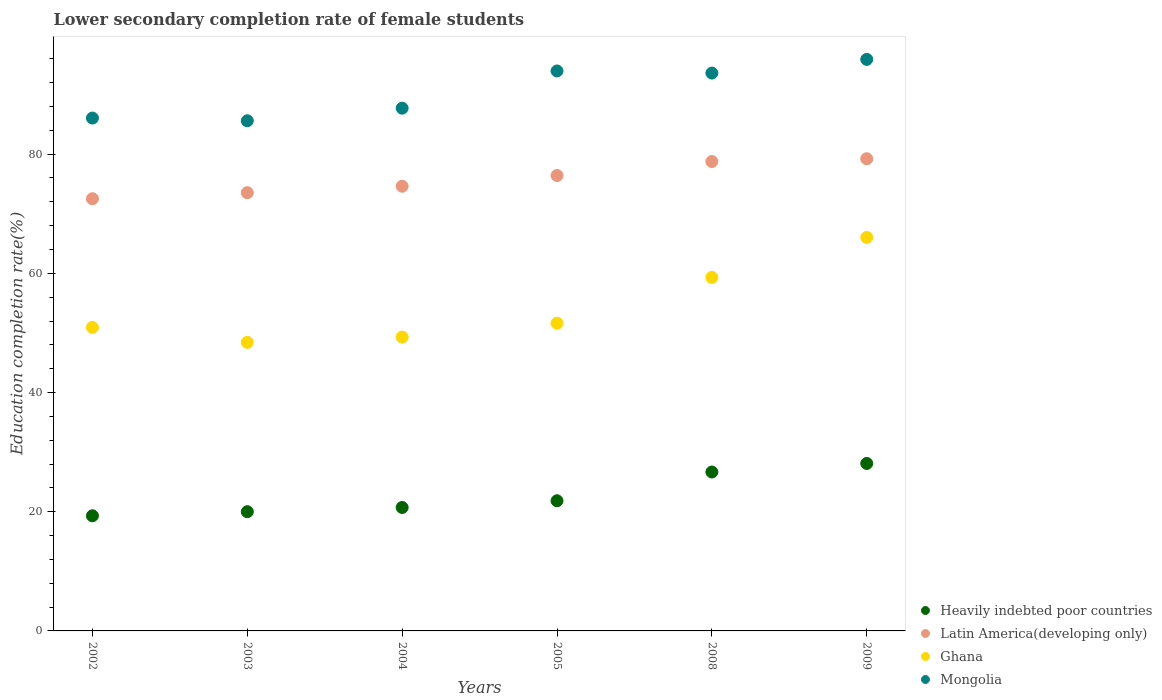Is the number of dotlines equal to the number of legend labels?
Your answer should be very brief. Yes. What is the lower secondary completion rate of female students in Ghana in 2004?
Make the answer very short. 49.3. Across all years, what is the maximum lower secondary completion rate of female students in Heavily indebted poor countries?
Provide a short and direct response. 28.1. Across all years, what is the minimum lower secondary completion rate of female students in Heavily indebted poor countries?
Provide a short and direct response. 19.32. In which year was the lower secondary completion rate of female students in Heavily indebted poor countries minimum?
Give a very brief answer. 2002. What is the total lower secondary completion rate of female students in Heavily indebted poor countries in the graph?
Your answer should be very brief. 136.63. What is the difference between the lower secondary completion rate of female students in Latin America(developing only) in 2005 and that in 2008?
Make the answer very short. -2.35. What is the difference between the lower secondary completion rate of female students in Heavily indebted poor countries in 2002 and the lower secondary completion rate of female students in Ghana in 2009?
Keep it short and to the point. -46.71. What is the average lower secondary completion rate of female students in Mongolia per year?
Your answer should be compact. 90.47. In the year 2009, what is the difference between the lower secondary completion rate of female students in Heavily indebted poor countries and lower secondary completion rate of female students in Latin America(developing only)?
Give a very brief answer. -51.13. In how many years, is the lower secondary completion rate of female students in Latin America(developing only) greater than 68 %?
Provide a succinct answer. 6. What is the ratio of the lower secondary completion rate of female students in Heavily indebted poor countries in 2002 to that in 2004?
Your answer should be compact. 0.93. Is the lower secondary completion rate of female students in Mongolia in 2004 less than that in 2009?
Give a very brief answer. Yes. What is the difference between the highest and the second highest lower secondary completion rate of female students in Mongolia?
Make the answer very short. 1.94. What is the difference between the highest and the lowest lower secondary completion rate of female students in Ghana?
Give a very brief answer. 17.62. Is it the case that in every year, the sum of the lower secondary completion rate of female students in Ghana and lower secondary completion rate of female students in Mongolia  is greater than the sum of lower secondary completion rate of female students in Latin America(developing only) and lower secondary completion rate of female students in Heavily indebted poor countries?
Ensure brevity in your answer.  No. What is the difference between two consecutive major ticks on the Y-axis?
Your response must be concise. 20. Does the graph contain grids?
Ensure brevity in your answer.  No. Where does the legend appear in the graph?
Ensure brevity in your answer.  Bottom right. How are the legend labels stacked?
Give a very brief answer. Vertical. What is the title of the graph?
Provide a short and direct response. Lower secondary completion rate of female students. Does "Guinea" appear as one of the legend labels in the graph?
Offer a very short reply. No. What is the label or title of the Y-axis?
Keep it short and to the point. Education completion rate(%). What is the Education completion rate(%) in Heavily indebted poor countries in 2002?
Your answer should be compact. 19.32. What is the Education completion rate(%) in Latin America(developing only) in 2002?
Offer a terse response. 72.52. What is the Education completion rate(%) of Ghana in 2002?
Provide a succinct answer. 50.93. What is the Education completion rate(%) of Mongolia in 2002?
Make the answer very short. 86.06. What is the Education completion rate(%) of Heavily indebted poor countries in 2003?
Provide a succinct answer. 20. What is the Education completion rate(%) of Latin America(developing only) in 2003?
Keep it short and to the point. 73.53. What is the Education completion rate(%) of Ghana in 2003?
Your answer should be very brief. 48.41. What is the Education completion rate(%) of Mongolia in 2003?
Provide a short and direct response. 85.6. What is the Education completion rate(%) in Heavily indebted poor countries in 2004?
Provide a short and direct response. 20.71. What is the Education completion rate(%) of Latin America(developing only) in 2004?
Provide a succinct answer. 74.61. What is the Education completion rate(%) of Ghana in 2004?
Offer a very short reply. 49.3. What is the Education completion rate(%) of Mongolia in 2004?
Ensure brevity in your answer.  87.71. What is the Education completion rate(%) in Heavily indebted poor countries in 2005?
Offer a terse response. 21.84. What is the Education completion rate(%) in Latin America(developing only) in 2005?
Offer a terse response. 76.41. What is the Education completion rate(%) in Ghana in 2005?
Keep it short and to the point. 51.63. What is the Education completion rate(%) of Mongolia in 2005?
Your answer should be compact. 93.96. What is the Education completion rate(%) in Heavily indebted poor countries in 2008?
Keep it short and to the point. 26.66. What is the Education completion rate(%) in Latin America(developing only) in 2008?
Provide a succinct answer. 78.76. What is the Education completion rate(%) in Ghana in 2008?
Make the answer very short. 59.32. What is the Education completion rate(%) in Mongolia in 2008?
Your answer should be very brief. 93.6. What is the Education completion rate(%) in Heavily indebted poor countries in 2009?
Offer a very short reply. 28.1. What is the Education completion rate(%) in Latin America(developing only) in 2009?
Provide a succinct answer. 79.23. What is the Education completion rate(%) of Ghana in 2009?
Keep it short and to the point. 66.03. What is the Education completion rate(%) in Mongolia in 2009?
Offer a terse response. 95.9. Across all years, what is the maximum Education completion rate(%) of Heavily indebted poor countries?
Provide a short and direct response. 28.1. Across all years, what is the maximum Education completion rate(%) in Latin America(developing only)?
Give a very brief answer. 79.23. Across all years, what is the maximum Education completion rate(%) in Ghana?
Keep it short and to the point. 66.03. Across all years, what is the maximum Education completion rate(%) in Mongolia?
Your answer should be compact. 95.9. Across all years, what is the minimum Education completion rate(%) in Heavily indebted poor countries?
Give a very brief answer. 19.32. Across all years, what is the minimum Education completion rate(%) in Latin America(developing only)?
Offer a very short reply. 72.52. Across all years, what is the minimum Education completion rate(%) in Ghana?
Give a very brief answer. 48.41. Across all years, what is the minimum Education completion rate(%) in Mongolia?
Keep it short and to the point. 85.6. What is the total Education completion rate(%) in Heavily indebted poor countries in the graph?
Provide a succinct answer. 136.63. What is the total Education completion rate(%) in Latin America(developing only) in the graph?
Your response must be concise. 455.06. What is the total Education completion rate(%) in Ghana in the graph?
Ensure brevity in your answer.  325.62. What is the total Education completion rate(%) of Mongolia in the graph?
Provide a short and direct response. 542.82. What is the difference between the Education completion rate(%) in Heavily indebted poor countries in 2002 and that in 2003?
Your answer should be compact. -0.69. What is the difference between the Education completion rate(%) in Latin America(developing only) in 2002 and that in 2003?
Offer a terse response. -1.01. What is the difference between the Education completion rate(%) in Ghana in 2002 and that in 2003?
Offer a terse response. 2.51. What is the difference between the Education completion rate(%) of Mongolia in 2002 and that in 2003?
Provide a short and direct response. 0.46. What is the difference between the Education completion rate(%) in Heavily indebted poor countries in 2002 and that in 2004?
Give a very brief answer. -1.4. What is the difference between the Education completion rate(%) in Latin America(developing only) in 2002 and that in 2004?
Your response must be concise. -2.1. What is the difference between the Education completion rate(%) of Ghana in 2002 and that in 2004?
Give a very brief answer. 1.63. What is the difference between the Education completion rate(%) of Mongolia in 2002 and that in 2004?
Offer a very short reply. -1.66. What is the difference between the Education completion rate(%) of Heavily indebted poor countries in 2002 and that in 2005?
Provide a short and direct response. -2.52. What is the difference between the Education completion rate(%) of Latin America(developing only) in 2002 and that in 2005?
Provide a short and direct response. -3.9. What is the difference between the Education completion rate(%) in Ghana in 2002 and that in 2005?
Ensure brevity in your answer.  -0.7. What is the difference between the Education completion rate(%) in Mongolia in 2002 and that in 2005?
Your response must be concise. -7.9. What is the difference between the Education completion rate(%) of Heavily indebted poor countries in 2002 and that in 2008?
Your response must be concise. -7.34. What is the difference between the Education completion rate(%) of Latin America(developing only) in 2002 and that in 2008?
Your response must be concise. -6.24. What is the difference between the Education completion rate(%) of Ghana in 2002 and that in 2008?
Make the answer very short. -8.39. What is the difference between the Education completion rate(%) of Mongolia in 2002 and that in 2008?
Give a very brief answer. -7.55. What is the difference between the Education completion rate(%) of Heavily indebted poor countries in 2002 and that in 2009?
Your answer should be very brief. -8.78. What is the difference between the Education completion rate(%) in Latin America(developing only) in 2002 and that in 2009?
Keep it short and to the point. -6.71. What is the difference between the Education completion rate(%) in Ghana in 2002 and that in 2009?
Offer a terse response. -15.1. What is the difference between the Education completion rate(%) in Mongolia in 2002 and that in 2009?
Your response must be concise. -9.84. What is the difference between the Education completion rate(%) of Heavily indebted poor countries in 2003 and that in 2004?
Provide a succinct answer. -0.71. What is the difference between the Education completion rate(%) of Latin America(developing only) in 2003 and that in 2004?
Provide a succinct answer. -1.09. What is the difference between the Education completion rate(%) of Ghana in 2003 and that in 2004?
Your answer should be very brief. -0.89. What is the difference between the Education completion rate(%) of Mongolia in 2003 and that in 2004?
Your answer should be very brief. -2.11. What is the difference between the Education completion rate(%) in Heavily indebted poor countries in 2003 and that in 2005?
Keep it short and to the point. -1.83. What is the difference between the Education completion rate(%) of Latin America(developing only) in 2003 and that in 2005?
Give a very brief answer. -2.88. What is the difference between the Education completion rate(%) in Ghana in 2003 and that in 2005?
Your answer should be compact. -3.21. What is the difference between the Education completion rate(%) in Mongolia in 2003 and that in 2005?
Your answer should be compact. -8.36. What is the difference between the Education completion rate(%) in Heavily indebted poor countries in 2003 and that in 2008?
Keep it short and to the point. -6.66. What is the difference between the Education completion rate(%) of Latin America(developing only) in 2003 and that in 2008?
Your answer should be compact. -5.23. What is the difference between the Education completion rate(%) of Ghana in 2003 and that in 2008?
Offer a very short reply. -10.9. What is the difference between the Education completion rate(%) in Mongolia in 2003 and that in 2008?
Your response must be concise. -8. What is the difference between the Education completion rate(%) in Heavily indebted poor countries in 2003 and that in 2009?
Provide a short and direct response. -8.09. What is the difference between the Education completion rate(%) of Latin America(developing only) in 2003 and that in 2009?
Your answer should be compact. -5.7. What is the difference between the Education completion rate(%) in Ghana in 2003 and that in 2009?
Offer a terse response. -17.62. What is the difference between the Education completion rate(%) of Mongolia in 2003 and that in 2009?
Keep it short and to the point. -10.3. What is the difference between the Education completion rate(%) in Heavily indebted poor countries in 2004 and that in 2005?
Make the answer very short. -1.12. What is the difference between the Education completion rate(%) in Latin America(developing only) in 2004 and that in 2005?
Make the answer very short. -1.8. What is the difference between the Education completion rate(%) in Ghana in 2004 and that in 2005?
Provide a succinct answer. -2.33. What is the difference between the Education completion rate(%) in Mongolia in 2004 and that in 2005?
Provide a succinct answer. -6.24. What is the difference between the Education completion rate(%) of Heavily indebted poor countries in 2004 and that in 2008?
Provide a short and direct response. -5.95. What is the difference between the Education completion rate(%) in Latin America(developing only) in 2004 and that in 2008?
Provide a succinct answer. -4.14. What is the difference between the Education completion rate(%) in Ghana in 2004 and that in 2008?
Provide a short and direct response. -10.02. What is the difference between the Education completion rate(%) in Mongolia in 2004 and that in 2008?
Provide a short and direct response. -5.89. What is the difference between the Education completion rate(%) in Heavily indebted poor countries in 2004 and that in 2009?
Your answer should be compact. -7.38. What is the difference between the Education completion rate(%) in Latin America(developing only) in 2004 and that in 2009?
Your answer should be very brief. -4.62. What is the difference between the Education completion rate(%) of Ghana in 2004 and that in 2009?
Provide a short and direct response. -16.73. What is the difference between the Education completion rate(%) in Mongolia in 2004 and that in 2009?
Provide a short and direct response. -8.19. What is the difference between the Education completion rate(%) in Heavily indebted poor countries in 2005 and that in 2008?
Ensure brevity in your answer.  -4.83. What is the difference between the Education completion rate(%) in Latin America(developing only) in 2005 and that in 2008?
Provide a succinct answer. -2.35. What is the difference between the Education completion rate(%) of Ghana in 2005 and that in 2008?
Your answer should be very brief. -7.69. What is the difference between the Education completion rate(%) in Mongolia in 2005 and that in 2008?
Provide a succinct answer. 0.36. What is the difference between the Education completion rate(%) in Heavily indebted poor countries in 2005 and that in 2009?
Give a very brief answer. -6.26. What is the difference between the Education completion rate(%) in Latin America(developing only) in 2005 and that in 2009?
Provide a short and direct response. -2.82. What is the difference between the Education completion rate(%) of Ghana in 2005 and that in 2009?
Ensure brevity in your answer.  -14.41. What is the difference between the Education completion rate(%) of Mongolia in 2005 and that in 2009?
Give a very brief answer. -1.94. What is the difference between the Education completion rate(%) in Heavily indebted poor countries in 2008 and that in 2009?
Ensure brevity in your answer.  -1.44. What is the difference between the Education completion rate(%) of Latin America(developing only) in 2008 and that in 2009?
Offer a terse response. -0.47. What is the difference between the Education completion rate(%) of Ghana in 2008 and that in 2009?
Your answer should be compact. -6.71. What is the difference between the Education completion rate(%) of Mongolia in 2008 and that in 2009?
Your answer should be very brief. -2.3. What is the difference between the Education completion rate(%) of Heavily indebted poor countries in 2002 and the Education completion rate(%) of Latin America(developing only) in 2003?
Make the answer very short. -54.21. What is the difference between the Education completion rate(%) in Heavily indebted poor countries in 2002 and the Education completion rate(%) in Ghana in 2003?
Ensure brevity in your answer.  -29.1. What is the difference between the Education completion rate(%) in Heavily indebted poor countries in 2002 and the Education completion rate(%) in Mongolia in 2003?
Provide a short and direct response. -66.28. What is the difference between the Education completion rate(%) of Latin America(developing only) in 2002 and the Education completion rate(%) of Ghana in 2003?
Give a very brief answer. 24.1. What is the difference between the Education completion rate(%) in Latin America(developing only) in 2002 and the Education completion rate(%) in Mongolia in 2003?
Your answer should be very brief. -13.08. What is the difference between the Education completion rate(%) of Ghana in 2002 and the Education completion rate(%) of Mongolia in 2003?
Offer a very short reply. -34.67. What is the difference between the Education completion rate(%) of Heavily indebted poor countries in 2002 and the Education completion rate(%) of Latin America(developing only) in 2004?
Provide a succinct answer. -55.3. What is the difference between the Education completion rate(%) of Heavily indebted poor countries in 2002 and the Education completion rate(%) of Ghana in 2004?
Offer a terse response. -29.98. What is the difference between the Education completion rate(%) of Heavily indebted poor countries in 2002 and the Education completion rate(%) of Mongolia in 2004?
Provide a succinct answer. -68.39. What is the difference between the Education completion rate(%) in Latin America(developing only) in 2002 and the Education completion rate(%) in Ghana in 2004?
Offer a very short reply. 23.22. What is the difference between the Education completion rate(%) in Latin America(developing only) in 2002 and the Education completion rate(%) in Mongolia in 2004?
Make the answer very short. -15.19. What is the difference between the Education completion rate(%) in Ghana in 2002 and the Education completion rate(%) in Mongolia in 2004?
Your answer should be compact. -36.78. What is the difference between the Education completion rate(%) in Heavily indebted poor countries in 2002 and the Education completion rate(%) in Latin America(developing only) in 2005?
Provide a succinct answer. -57.1. What is the difference between the Education completion rate(%) in Heavily indebted poor countries in 2002 and the Education completion rate(%) in Ghana in 2005?
Provide a succinct answer. -32.31. What is the difference between the Education completion rate(%) of Heavily indebted poor countries in 2002 and the Education completion rate(%) of Mongolia in 2005?
Ensure brevity in your answer.  -74.64. What is the difference between the Education completion rate(%) of Latin America(developing only) in 2002 and the Education completion rate(%) of Ghana in 2005?
Give a very brief answer. 20.89. What is the difference between the Education completion rate(%) in Latin America(developing only) in 2002 and the Education completion rate(%) in Mongolia in 2005?
Your answer should be compact. -21.44. What is the difference between the Education completion rate(%) in Ghana in 2002 and the Education completion rate(%) in Mongolia in 2005?
Provide a succinct answer. -43.03. What is the difference between the Education completion rate(%) in Heavily indebted poor countries in 2002 and the Education completion rate(%) in Latin America(developing only) in 2008?
Give a very brief answer. -59.44. What is the difference between the Education completion rate(%) of Heavily indebted poor countries in 2002 and the Education completion rate(%) of Ghana in 2008?
Make the answer very short. -40. What is the difference between the Education completion rate(%) of Heavily indebted poor countries in 2002 and the Education completion rate(%) of Mongolia in 2008?
Ensure brevity in your answer.  -74.28. What is the difference between the Education completion rate(%) in Latin America(developing only) in 2002 and the Education completion rate(%) in Ghana in 2008?
Your response must be concise. 13.2. What is the difference between the Education completion rate(%) of Latin America(developing only) in 2002 and the Education completion rate(%) of Mongolia in 2008?
Give a very brief answer. -21.08. What is the difference between the Education completion rate(%) in Ghana in 2002 and the Education completion rate(%) in Mongolia in 2008?
Keep it short and to the point. -42.67. What is the difference between the Education completion rate(%) in Heavily indebted poor countries in 2002 and the Education completion rate(%) in Latin America(developing only) in 2009?
Offer a terse response. -59.91. What is the difference between the Education completion rate(%) of Heavily indebted poor countries in 2002 and the Education completion rate(%) of Ghana in 2009?
Offer a very short reply. -46.71. What is the difference between the Education completion rate(%) of Heavily indebted poor countries in 2002 and the Education completion rate(%) of Mongolia in 2009?
Provide a short and direct response. -76.58. What is the difference between the Education completion rate(%) of Latin America(developing only) in 2002 and the Education completion rate(%) of Ghana in 2009?
Offer a terse response. 6.48. What is the difference between the Education completion rate(%) in Latin America(developing only) in 2002 and the Education completion rate(%) in Mongolia in 2009?
Keep it short and to the point. -23.38. What is the difference between the Education completion rate(%) of Ghana in 2002 and the Education completion rate(%) of Mongolia in 2009?
Make the answer very short. -44.97. What is the difference between the Education completion rate(%) in Heavily indebted poor countries in 2003 and the Education completion rate(%) in Latin America(developing only) in 2004?
Offer a terse response. -54.61. What is the difference between the Education completion rate(%) of Heavily indebted poor countries in 2003 and the Education completion rate(%) of Ghana in 2004?
Your answer should be compact. -29.3. What is the difference between the Education completion rate(%) of Heavily indebted poor countries in 2003 and the Education completion rate(%) of Mongolia in 2004?
Ensure brevity in your answer.  -67.71. What is the difference between the Education completion rate(%) of Latin America(developing only) in 2003 and the Education completion rate(%) of Ghana in 2004?
Make the answer very short. 24.23. What is the difference between the Education completion rate(%) in Latin America(developing only) in 2003 and the Education completion rate(%) in Mongolia in 2004?
Make the answer very short. -14.18. What is the difference between the Education completion rate(%) of Ghana in 2003 and the Education completion rate(%) of Mongolia in 2004?
Keep it short and to the point. -39.3. What is the difference between the Education completion rate(%) in Heavily indebted poor countries in 2003 and the Education completion rate(%) in Latin America(developing only) in 2005?
Offer a terse response. -56.41. What is the difference between the Education completion rate(%) of Heavily indebted poor countries in 2003 and the Education completion rate(%) of Ghana in 2005?
Provide a short and direct response. -31.62. What is the difference between the Education completion rate(%) of Heavily indebted poor countries in 2003 and the Education completion rate(%) of Mongolia in 2005?
Ensure brevity in your answer.  -73.95. What is the difference between the Education completion rate(%) of Latin America(developing only) in 2003 and the Education completion rate(%) of Ghana in 2005?
Provide a short and direct response. 21.9. What is the difference between the Education completion rate(%) in Latin America(developing only) in 2003 and the Education completion rate(%) in Mongolia in 2005?
Make the answer very short. -20.43. What is the difference between the Education completion rate(%) in Ghana in 2003 and the Education completion rate(%) in Mongolia in 2005?
Your answer should be very brief. -45.54. What is the difference between the Education completion rate(%) in Heavily indebted poor countries in 2003 and the Education completion rate(%) in Latin America(developing only) in 2008?
Your response must be concise. -58.75. What is the difference between the Education completion rate(%) of Heavily indebted poor countries in 2003 and the Education completion rate(%) of Ghana in 2008?
Ensure brevity in your answer.  -39.31. What is the difference between the Education completion rate(%) in Heavily indebted poor countries in 2003 and the Education completion rate(%) in Mongolia in 2008?
Your response must be concise. -73.6. What is the difference between the Education completion rate(%) in Latin America(developing only) in 2003 and the Education completion rate(%) in Ghana in 2008?
Your response must be concise. 14.21. What is the difference between the Education completion rate(%) of Latin America(developing only) in 2003 and the Education completion rate(%) of Mongolia in 2008?
Keep it short and to the point. -20.07. What is the difference between the Education completion rate(%) in Ghana in 2003 and the Education completion rate(%) in Mongolia in 2008?
Offer a very short reply. -45.19. What is the difference between the Education completion rate(%) in Heavily indebted poor countries in 2003 and the Education completion rate(%) in Latin America(developing only) in 2009?
Make the answer very short. -59.22. What is the difference between the Education completion rate(%) of Heavily indebted poor countries in 2003 and the Education completion rate(%) of Ghana in 2009?
Make the answer very short. -46.03. What is the difference between the Education completion rate(%) in Heavily indebted poor countries in 2003 and the Education completion rate(%) in Mongolia in 2009?
Provide a short and direct response. -75.89. What is the difference between the Education completion rate(%) of Latin America(developing only) in 2003 and the Education completion rate(%) of Ghana in 2009?
Provide a succinct answer. 7.5. What is the difference between the Education completion rate(%) in Latin America(developing only) in 2003 and the Education completion rate(%) in Mongolia in 2009?
Ensure brevity in your answer.  -22.37. What is the difference between the Education completion rate(%) in Ghana in 2003 and the Education completion rate(%) in Mongolia in 2009?
Provide a short and direct response. -47.48. What is the difference between the Education completion rate(%) of Heavily indebted poor countries in 2004 and the Education completion rate(%) of Latin America(developing only) in 2005?
Your answer should be compact. -55.7. What is the difference between the Education completion rate(%) of Heavily indebted poor countries in 2004 and the Education completion rate(%) of Ghana in 2005?
Provide a succinct answer. -30.91. What is the difference between the Education completion rate(%) in Heavily indebted poor countries in 2004 and the Education completion rate(%) in Mongolia in 2005?
Offer a terse response. -73.24. What is the difference between the Education completion rate(%) in Latin America(developing only) in 2004 and the Education completion rate(%) in Ghana in 2005?
Keep it short and to the point. 22.99. What is the difference between the Education completion rate(%) in Latin America(developing only) in 2004 and the Education completion rate(%) in Mongolia in 2005?
Provide a succinct answer. -19.34. What is the difference between the Education completion rate(%) in Ghana in 2004 and the Education completion rate(%) in Mongolia in 2005?
Offer a very short reply. -44.66. What is the difference between the Education completion rate(%) in Heavily indebted poor countries in 2004 and the Education completion rate(%) in Latin America(developing only) in 2008?
Ensure brevity in your answer.  -58.05. What is the difference between the Education completion rate(%) of Heavily indebted poor countries in 2004 and the Education completion rate(%) of Ghana in 2008?
Your response must be concise. -38.6. What is the difference between the Education completion rate(%) of Heavily indebted poor countries in 2004 and the Education completion rate(%) of Mongolia in 2008?
Make the answer very short. -72.89. What is the difference between the Education completion rate(%) of Latin America(developing only) in 2004 and the Education completion rate(%) of Ghana in 2008?
Offer a very short reply. 15.3. What is the difference between the Education completion rate(%) of Latin America(developing only) in 2004 and the Education completion rate(%) of Mongolia in 2008?
Offer a very short reply. -18.99. What is the difference between the Education completion rate(%) in Ghana in 2004 and the Education completion rate(%) in Mongolia in 2008?
Offer a terse response. -44.3. What is the difference between the Education completion rate(%) of Heavily indebted poor countries in 2004 and the Education completion rate(%) of Latin America(developing only) in 2009?
Ensure brevity in your answer.  -58.52. What is the difference between the Education completion rate(%) in Heavily indebted poor countries in 2004 and the Education completion rate(%) in Ghana in 2009?
Make the answer very short. -45.32. What is the difference between the Education completion rate(%) of Heavily indebted poor countries in 2004 and the Education completion rate(%) of Mongolia in 2009?
Provide a short and direct response. -75.18. What is the difference between the Education completion rate(%) of Latin America(developing only) in 2004 and the Education completion rate(%) of Ghana in 2009?
Keep it short and to the point. 8.58. What is the difference between the Education completion rate(%) of Latin America(developing only) in 2004 and the Education completion rate(%) of Mongolia in 2009?
Offer a terse response. -21.28. What is the difference between the Education completion rate(%) in Ghana in 2004 and the Education completion rate(%) in Mongolia in 2009?
Your response must be concise. -46.6. What is the difference between the Education completion rate(%) of Heavily indebted poor countries in 2005 and the Education completion rate(%) of Latin America(developing only) in 2008?
Give a very brief answer. -56.92. What is the difference between the Education completion rate(%) in Heavily indebted poor countries in 2005 and the Education completion rate(%) in Ghana in 2008?
Provide a succinct answer. -37.48. What is the difference between the Education completion rate(%) in Heavily indebted poor countries in 2005 and the Education completion rate(%) in Mongolia in 2008?
Make the answer very short. -71.76. What is the difference between the Education completion rate(%) in Latin America(developing only) in 2005 and the Education completion rate(%) in Ghana in 2008?
Provide a short and direct response. 17.1. What is the difference between the Education completion rate(%) in Latin America(developing only) in 2005 and the Education completion rate(%) in Mongolia in 2008?
Make the answer very short. -17.19. What is the difference between the Education completion rate(%) in Ghana in 2005 and the Education completion rate(%) in Mongolia in 2008?
Your answer should be compact. -41.97. What is the difference between the Education completion rate(%) in Heavily indebted poor countries in 2005 and the Education completion rate(%) in Latin America(developing only) in 2009?
Your response must be concise. -57.39. What is the difference between the Education completion rate(%) in Heavily indebted poor countries in 2005 and the Education completion rate(%) in Ghana in 2009?
Offer a terse response. -44.2. What is the difference between the Education completion rate(%) in Heavily indebted poor countries in 2005 and the Education completion rate(%) in Mongolia in 2009?
Provide a succinct answer. -74.06. What is the difference between the Education completion rate(%) of Latin America(developing only) in 2005 and the Education completion rate(%) of Ghana in 2009?
Ensure brevity in your answer.  10.38. What is the difference between the Education completion rate(%) of Latin America(developing only) in 2005 and the Education completion rate(%) of Mongolia in 2009?
Provide a succinct answer. -19.48. What is the difference between the Education completion rate(%) of Ghana in 2005 and the Education completion rate(%) of Mongolia in 2009?
Provide a short and direct response. -44.27. What is the difference between the Education completion rate(%) in Heavily indebted poor countries in 2008 and the Education completion rate(%) in Latin America(developing only) in 2009?
Keep it short and to the point. -52.57. What is the difference between the Education completion rate(%) in Heavily indebted poor countries in 2008 and the Education completion rate(%) in Ghana in 2009?
Your response must be concise. -39.37. What is the difference between the Education completion rate(%) of Heavily indebted poor countries in 2008 and the Education completion rate(%) of Mongolia in 2009?
Your answer should be very brief. -69.23. What is the difference between the Education completion rate(%) of Latin America(developing only) in 2008 and the Education completion rate(%) of Ghana in 2009?
Your response must be concise. 12.73. What is the difference between the Education completion rate(%) in Latin America(developing only) in 2008 and the Education completion rate(%) in Mongolia in 2009?
Your answer should be compact. -17.14. What is the difference between the Education completion rate(%) in Ghana in 2008 and the Education completion rate(%) in Mongolia in 2009?
Provide a short and direct response. -36.58. What is the average Education completion rate(%) of Heavily indebted poor countries per year?
Your answer should be very brief. 22.77. What is the average Education completion rate(%) in Latin America(developing only) per year?
Give a very brief answer. 75.84. What is the average Education completion rate(%) of Ghana per year?
Give a very brief answer. 54.27. What is the average Education completion rate(%) in Mongolia per year?
Make the answer very short. 90.47. In the year 2002, what is the difference between the Education completion rate(%) in Heavily indebted poor countries and Education completion rate(%) in Latin America(developing only)?
Provide a succinct answer. -53.2. In the year 2002, what is the difference between the Education completion rate(%) in Heavily indebted poor countries and Education completion rate(%) in Ghana?
Your response must be concise. -31.61. In the year 2002, what is the difference between the Education completion rate(%) of Heavily indebted poor countries and Education completion rate(%) of Mongolia?
Provide a short and direct response. -66.74. In the year 2002, what is the difference between the Education completion rate(%) of Latin America(developing only) and Education completion rate(%) of Ghana?
Offer a very short reply. 21.59. In the year 2002, what is the difference between the Education completion rate(%) in Latin America(developing only) and Education completion rate(%) in Mongolia?
Offer a terse response. -13.54. In the year 2002, what is the difference between the Education completion rate(%) of Ghana and Education completion rate(%) of Mongolia?
Ensure brevity in your answer.  -35.13. In the year 2003, what is the difference between the Education completion rate(%) in Heavily indebted poor countries and Education completion rate(%) in Latin America(developing only)?
Offer a very short reply. -53.52. In the year 2003, what is the difference between the Education completion rate(%) in Heavily indebted poor countries and Education completion rate(%) in Ghana?
Provide a short and direct response. -28.41. In the year 2003, what is the difference between the Education completion rate(%) of Heavily indebted poor countries and Education completion rate(%) of Mongolia?
Keep it short and to the point. -65.59. In the year 2003, what is the difference between the Education completion rate(%) in Latin America(developing only) and Education completion rate(%) in Ghana?
Offer a terse response. 25.11. In the year 2003, what is the difference between the Education completion rate(%) in Latin America(developing only) and Education completion rate(%) in Mongolia?
Your answer should be very brief. -12.07. In the year 2003, what is the difference between the Education completion rate(%) in Ghana and Education completion rate(%) in Mongolia?
Provide a succinct answer. -37.18. In the year 2004, what is the difference between the Education completion rate(%) in Heavily indebted poor countries and Education completion rate(%) in Latin America(developing only)?
Offer a very short reply. -53.9. In the year 2004, what is the difference between the Education completion rate(%) in Heavily indebted poor countries and Education completion rate(%) in Ghana?
Your answer should be very brief. -28.59. In the year 2004, what is the difference between the Education completion rate(%) in Heavily indebted poor countries and Education completion rate(%) in Mongolia?
Give a very brief answer. -67. In the year 2004, what is the difference between the Education completion rate(%) of Latin America(developing only) and Education completion rate(%) of Ghana?
Provide a short and direct response. 25.31. In the year 2004, what is the difference between the Education completion rate(%) of Latin America(developing only) and Education completion rate(%) of Mongolia?
Keep it short and to the point. -13.1. In the year 2004, what is the difference between the Education completion rate(%) in Ghana and Education completion rate(%) in Mongolia?
Provide a short and direct response. -38.41. In the year 2005, what is the difference between the Education completion rate(%) of Heavily indebted poor countries and Education completion rate(%) of Latin America(developing only)?
Your response must be concise. -54.58. In the year 2005, what is the difference between the Education completion rate(%) in Heavily indebted poor countries and Education completion rate(%) in Ghana?
Make the answer very short. -29.79. In the year 2005, what is the difference between the Education completion rate(%) in Heavily indebted poor countries and Education completion rate(%) in Mongolia?
Offer a very short reply. -72.12. In the year 2005, what is the difference between the Education completion rate(%) of Latin America(developing only) and Education completion rate(%) of Ghana?
Ensure brevity in your answer.  24.79. In the year 2005, what is the difference between the Education completion rate(%) of Latin America(developing only) and Education completion rate(%) of Mongolia?
Provide a succinct answer. -17.54. In the year 2005, what is the difference between the Education completion rate(%) of Ghana and Education completion rate(%) of Mongolia?
Your response must be concise. -42.33. In the year 2008, what is the difference between the Education completion rate(%) in Heavily indebted poor countries and Education completion rate(%) in Latin America(developing only)?
Make the answer very short. -52.1. In the year 2008, what is the difference between the Education completion rate(%) of Heavily indebted poor countries and Education completion rate(%) of Ghana?
Your response must be concise. -32.66. In the year 2008, what is the difference between the Education completion rate(%) of Heavily indebted poor countries and Education completion rate(%) of Mongolia?
Ensure brevity in your answer.  -66.94. In the year 2008, what is the difference between the Education completion rate(%) in Latin America(developing only) and Education completion rate(%) in Ghana?
Offer a terse response. 19.44. In the year 2008, what is the difference between the Education completion rate(%) of Latin America(developing only) and Education completion rate(%) of Mongolia?
Provide a short and direct response. -14.84. In the year 2008, what is the difference between the Education completion rate(%) in Ghana and Education completion rate(%) in Mongolia?
Ensure brevity in your answer.  -34.28. In the year 2009, what is the difference between the Education completion rate(%) of Heavily indebted poor countries and Education completion rate(%) of Latin America(developing only)?
Offer a very short reply. -51.13. In the year 2009, what is the difference between the Education completion rate(%) in Heavily indebted poor countries and Education completion rate(%) in Ghana?
Your response must be concise. -37.93. In the year 2009, what is the difference between the Education completion rate(%) of Heavily indebted poor countries and Education completion rate(%) of Mongolia?
Make the answer very short. -67.8. In the year 2009, what is the difference between the Education completion rate(%) of Latin America(developing only) and Education completion rate(%) of Ghana?
Ensure brevity in your answer.  13.2. In the year 2009, what is the difference between the Education completion rate(%) of Latin America(developing only) and Education completion rate(%) of Mongolia?
Give a very brief answer. -16.67. In the year 2009, what is the difference between the Education completion rate(%) of Ghana and Education completion rate(%) of Mongolia?
Make the answer very short. -29.86. What is the ratio of the Education completion rate(%) in Heavily indebted poor countries in 2002 to that in 2003?
Offer a terse response. 0.97. What is the ratio of the Education completion rate(%) of Latin America(developing only) in 2002 to that in 2003?
Offer a terse response. 0.99. What is the ratio of the Education completion rate(%) of Ghana in 2002 to that in 2003?
Offer a terse response. 1.05. What is the ratio of the Education completion rate(%) of Heavily indebted poor countries in 2002 to that in 2004?
Offer a terse response. 0.93. What is the ratio of the Education completion rate(%) of Latin America(developing only) in 2002 to that in 2004?
Ensure brevity in your answer.  0.97. What is the ratio of the Education completion rate(%) in Ghana in 2002 to that in 2004?
Provide a short and direct response. 1.03. What is the ratio of the Education completion rate(%) of Mongolia in 2002 to that in 2004?
Offer a very short reply. 0.98. What is the ratio of the Education completion rate(%) of Heavily indebted poor countries in 2002 to that in 2005?
Make the answer very short. 0.88. What is the ratio of the Education completion rate(%) of Latin America(developing only) in 2002 to that in 2005?
Your answer should be compact. 0.95. What is the ratio of the Education completion rate(%) in Ghana in 2002 to that in 2005?
Keep it short and to the point. 0.99. What is the ratio of the Education completion rate(%) in Mongolia in 2002 to that in 2005?
Provide a short and direct response. 0.92. What is the ratio of the Education completion rate(%) of Heavily indebted poor countries in 2002 to that in 2008?
Ensure brevity in your answer.  0.72. What is the ratio of the Education completion rate(%) of Latin America(developing only) in 2002 to that in 2008?
Ensure brevity in your answer.  0.92. What is the ratio of the Education completion rate(%) of Ghana in 2002 to that in 2008?
Your response must be concise. 0.86. What is the ratio of the Education completion rate(%) of Mongolia in 2002 to that in 2008?
Give a very brief answer. 0.92. What is the ratio of the Education completion rate(%) in Heavily indebted poor countries in 2002 to that in 2009?
Your response must be concise. 0.69. What is the ratio of the Education completion rate(%) of Latin America(developing only) in 2002 to that in 2009?
Offer a very short reply. 0.92. What is the ratio of the Education completion rate(%) in Ghana in 2002 to that in 2009?
Give a very brief answer. 0.77. What is the ratio of the Education completion rate(%) of Mongolia in 2002 to that in 2009?
Make the answer very short. 0.9. What is the ratio of the Education completion rate(%) in Heavily indebted poor countries in 2003 to that in 2004?
Ensure brevity in your answer.  0.97. What is the ratio of the Education completion rate(%) of Latin America(developing only) in 2003 to that in 2004?
Ensure brevity in your answer.  0.99. What is the ratio of the Education completion rate(%) in Ghana in 2003 to that in 2004?
Your answer should be very brief. 0.98. What is the ratio of the Education completion rate(%) of Mongolia in 2003 to that in 2004?
Ensure brevity in your answer.  0.98. What is the ratio of the Education completion rate(%) in Heavily indebted poor countries in 2003 to that in 2005?
Your answer should be compact. 0.92. What is the ratio of the Education completion rate(%) in Latin America(developing only) in 2003 to that in 2005?
Your response must be concise. 0.96. What is the ratio of the Education completion rate(%) in Ghana in 2003 to that in 2005?
Offer a very short reply. 0.94. What is the ratio of the Education completion rate(%) of Mongolia in 2003 to that in 2005?
Your answer should be very brief. 0.91. What is the ratio of the Education completion rate(%) in Heavily indebted poor countries in 2003 to that in 2008?
Provide a short and direct response. 0.75. What is the ratio of the Education completion rate(%) in Latin America(developing only) in 2003 to that in 2008?
Provide a short and direct response. 0.93. What is the ratio of the Education completion rate(%) of Ghana in 2003 to that in 2008?
Your response must be concise. 0.82. What is the ratio of the Education completion rate(%) in Mongolia in 2003 to that in 2008?
Your response must be concise. 0.91. What is the ratio of the Education completion rate(%) in Heavily indebted poor countries in 2003 to that in 2009?
Give a very brief answer. 0.71. What is the ratio of the Education completion rate(%) of Latin America(developing only) in 2003 to that in 2009?
Give a very brief answer. 0.93. What is the ratio of the Education completion rate(%) of Ghana in 2003 to that in 2009?
Make the answer very short. 0.73. What is the ratio of the Education completion rate(%) in Mongolia in 2003 to that in 2009?
Offer a very short reply. 0.89. What is the ratio of the Education completion rate(%) of Heavily indebted poor countries in 2004 to that in 2005?
Ensure brevity in your answer.  0.95. What is the ratio of the Education completion rate(%) in Latin America(developing only) in 2004 to that in 2005?
Keep it short and to the point. 0.98. What is the ratio of the Education completion rate(%) in Ghana in 2004 to that in 2005?
Your response must be concise. 0.95. What is the ratio of the Education completion rate(%) of Mongolia in 2004 to that in 2005?
Your response must be concise. 0.93. What is the ratio of the Education completion rate(%) in Heavily indebted poor countries in 2004 to that in 2008?
Your response must be concise. 0.78. What is the ratio of the Education completion rate(%) in Latin America(developing only) in 2004 to that in 2008?
Give a very brief answer. 0.95. What is the ratio of the Education completion rate(%) of Ghana in 2004 to that in 2008?
Your answer should be very brief. 0.83. What is the ratio of the Education completion rate(%) of Mongolia in 2004 to that in 2008?
Make the answer very short. 0.94. What is the ratio of the Education completion rate(%) of Heavily indebted poor countries in 2004 to that in 2009?
Make the answer very short. 0.74. What is the ratio of the Education completion rate(%) of Latin America(developing only) in 2004 to that in 2009?
Your answer should be very brief. 0.94. What is the ratio of the Education completion rate(%) in Ghana in 2004 to that in 2009?
Provide a short and direct response. 0.75. What is the ratio of the Education completion rate(%) of Mongolia in 2004 to that in 2009?
Give a very brief answer. 0.91. What is the ratio of the Education completion rate(%) in Heavily indebted poor countries in 2005 to that in 2008?
Offer a terse response. 0.82. What is the ratio of the Education completion rate(%) of Latin America(developing only) in 2005 to that in 2008?
Your response must be concise. 0.97. What is the ratio of the Education completion rate(%) in Ghana in 2005 to that in 2008?
Give a very brief answer. 0.87. What is the ratio of the Education completion rate(%) in Heavily indebted poor countries in 2005 to that in 2009?
Keep it short and to the point. 0.78. What is the ratio of the Education completion rate(%) of Latin America(developing only) in 2005 to that in 2009?
Your answer should be very brief. 0.96. What is the ratio of the Education completion rate(%) of Ghana in 2005 to that in 2009?
Your answer should be compact. 0.78. What is the ratio of the Education completion rate(%) of Mongolia in 2005 to that in 2009?
Your response must be concise. 0.98. What is the ratio of the Education completion rate(%) in Heavily indebted poor countries in 2008 to that in 2009?
Provide a short and direct response. 0.95. What is the ratio of the Education completion rate(%) of Ghana in 2008 to that in 2009?
Your answer should be very brief. 0.9. What is the ratio of the Education completion rate(%) in Mongolia in 2008 to that in 2009?
Make the answer very short. 0.98. What is the difference between the highest and the second highest Education completion rate(%) in Heavily indebted poor countries?
Your response must be concise. 1.44. What is the difference between the highest and the second highest Education completion rate(%) of Latin America(developing only)?
Provide a short and direct response. 0.47. What is the difference between the highest and the second highest Education completion rate(%) in Ghana?
Your answer should be very brief. 6.71. What is the difference between the highest and the second highest Education completion rate(%) of Mongolia?
Offer a very short reply. 1.94. What is the difference between the highest and the lowest Education completion rate(%) in Heavily indebted poor countries?
Your response must be concise. 8.78. What is the difference between the highest and the lowest Education completion rate(%) of Latin America(developing only)?
Your answer should be very brief. 6.71. What is the difference between the highest and the lowest Education completion rate(%) of Ghana?
Your answer should be very brief. 17.62. What is the difference between the highest and the lowest Education completion rate(%) in Mongolia?
Make the answer very short. 10.3. 